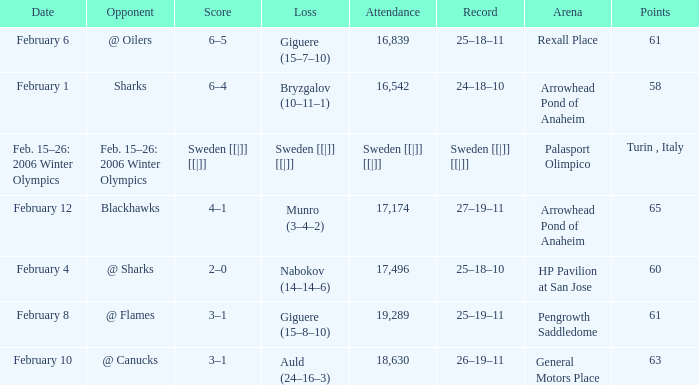What is the record at Palasport Olimpico? Sweden [[|]] [[|]]. 